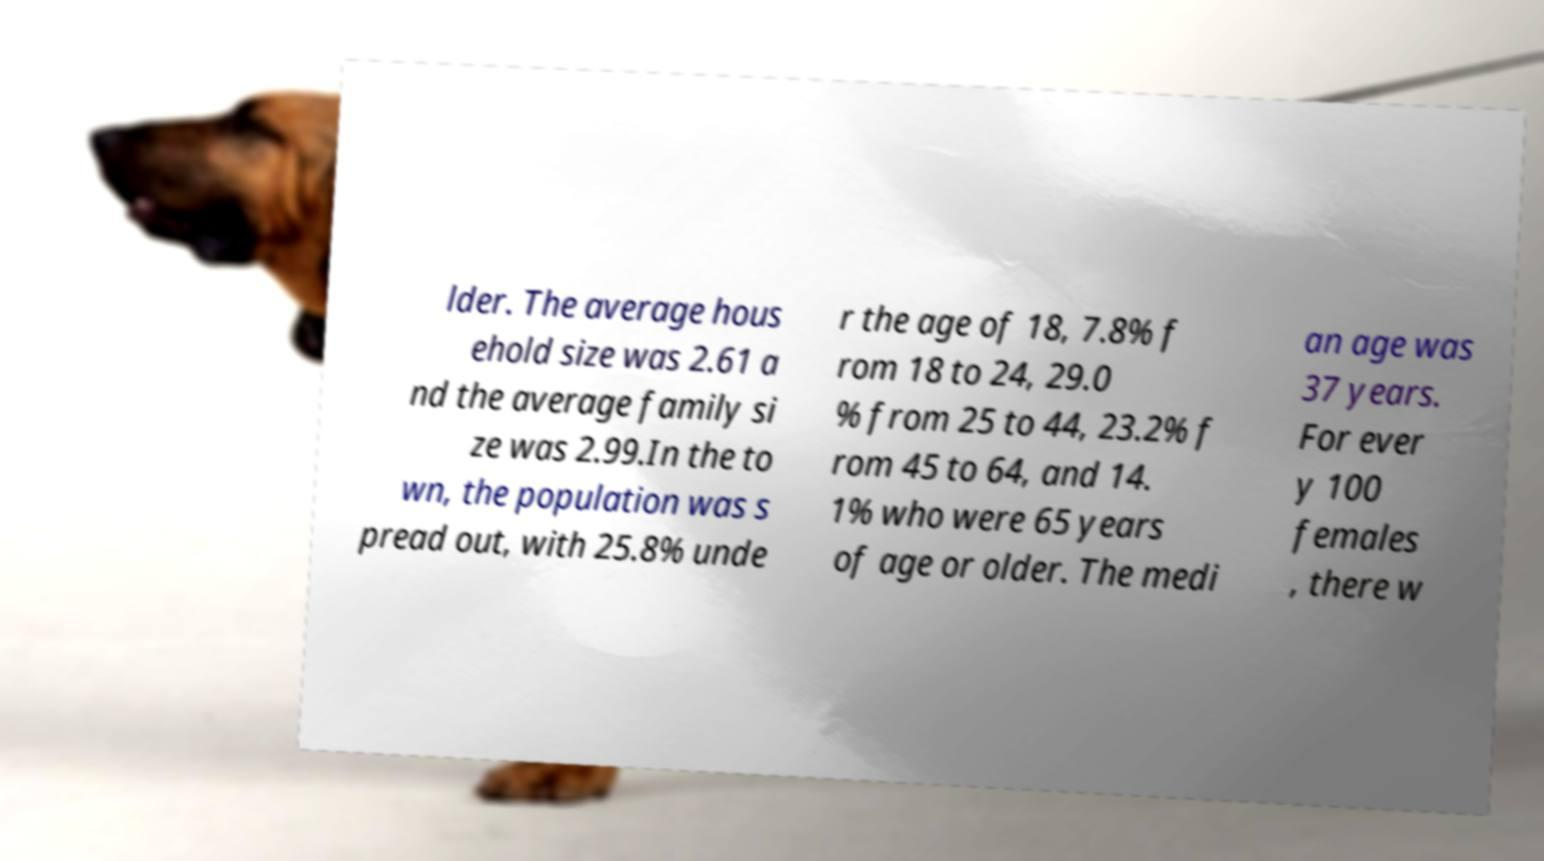I need the written content from this picture converted into text. Can you do that? lder. The average hous ehold size was 2.61 a nd the average family si ze was 2.99.In the to wn, the population was s pread out, with 25.8% unde r the age of 18, 7.8% f rom 18 to 24, 29.0 % from 25 to 44, 23.2% f rom 45 to 64, and 14. 1% who were 65 years of age or older. The medi an age was 37 years. For ever y 100 females , there w 